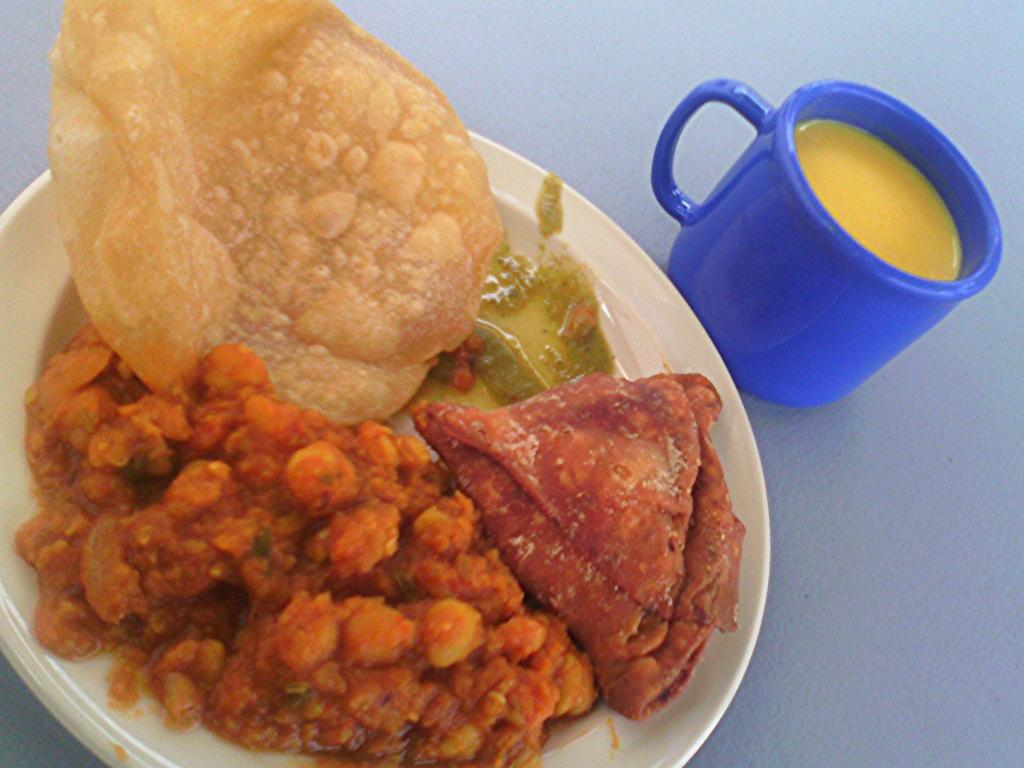What is on the plate that is visible in the image? The plate contains food items in the image. What is in the cup that is visible in the image? The cup contains liquid in the image. Where are the plate and cup located in the image? Both the plate and cup are on a surface in the image. What type of cookware is being used to cook the food on the plate in the image? There is no cookware visible in the image, as it only shows a plate with food items and a cup with liquid on a surface. 